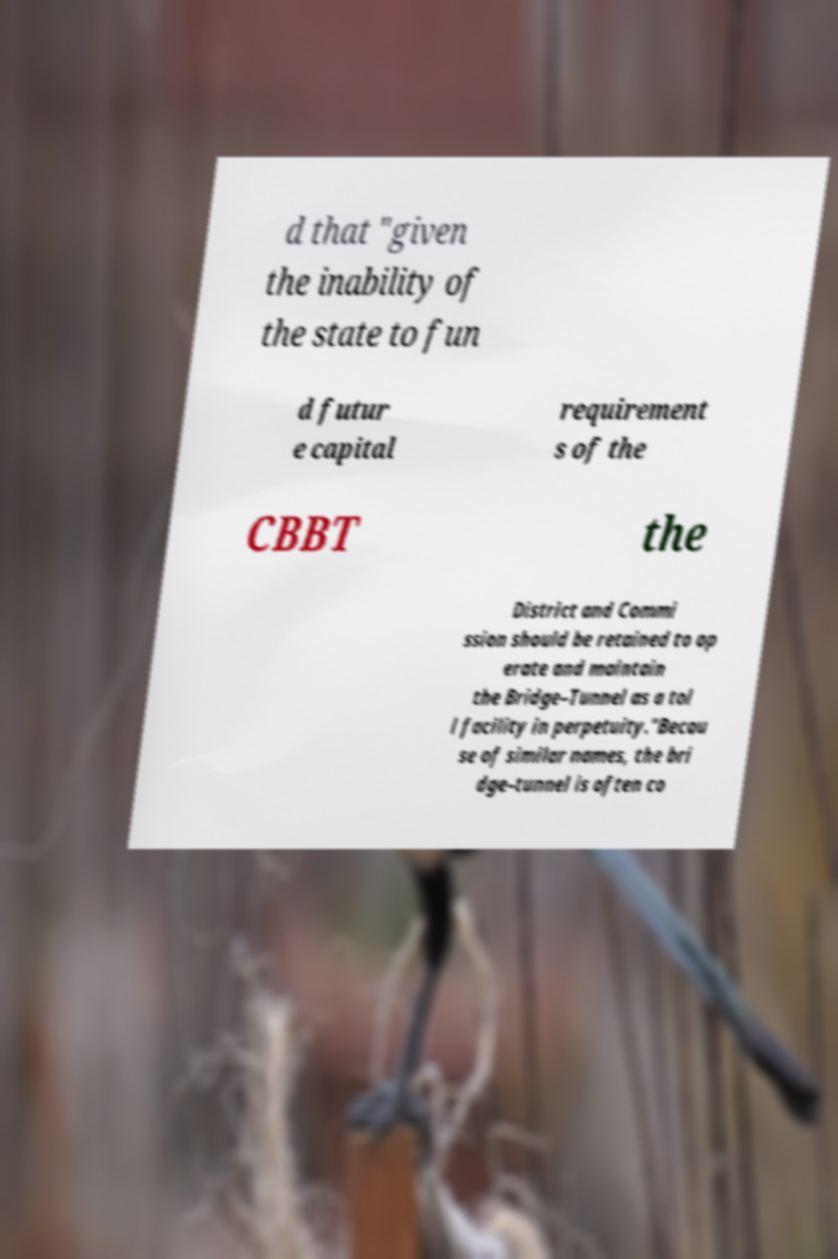I need the written content from this picture converted into text. Can you do that? d that "given the inability of the state to fun d futur e capital requirement s of the CBBT the District and Commi ssion should be retained to op erate and maintain the Bridge–Tunnel as a tol l facility in perpetuity."Becau se of similar names, the bri dge–tunnel is often co 